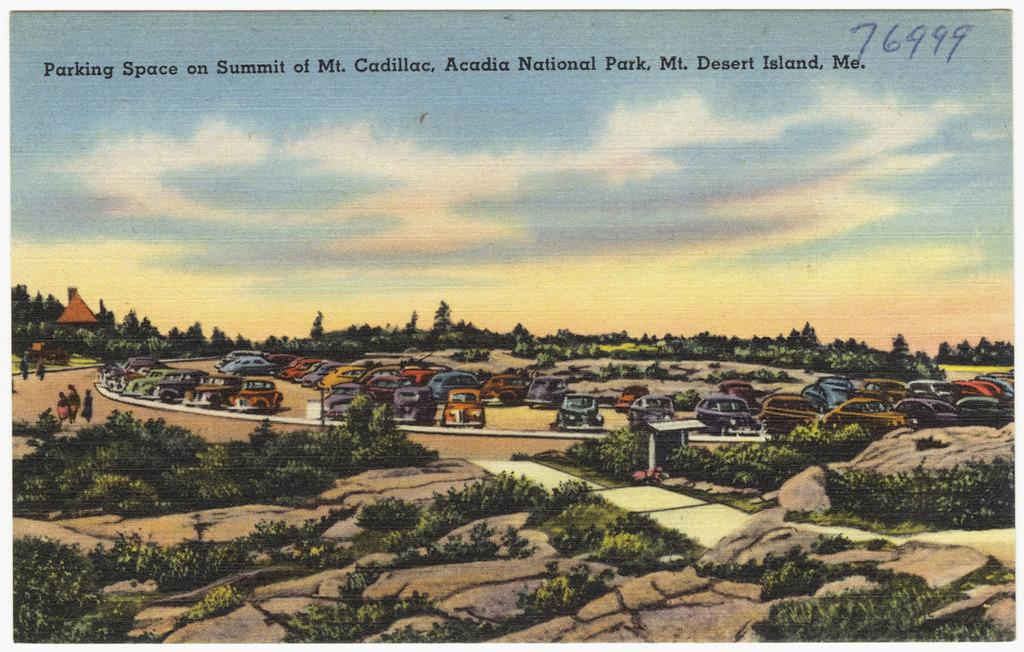<image>
Create a compact narrative representing the image presented. A postcard shows parking space at the top of Mt. Cadillac. 